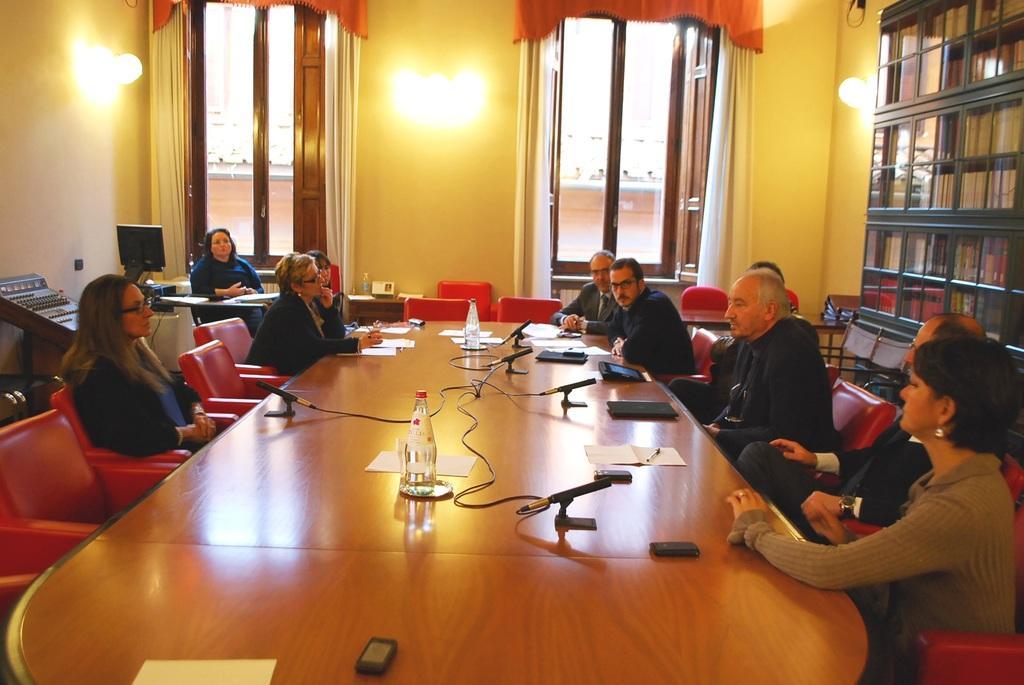How would you summarize this image in a sentence or two? A group of people are sitting on the chair around a chair. Here it's a window on the left there is a light. 